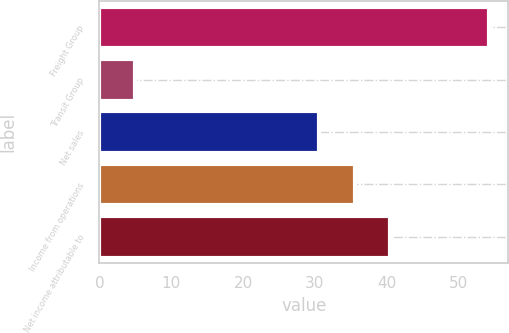<chart> <loc_0><loc_0><loc_500><loc_500><bar_chart><fcel>Freight Group<fcel>Transit Group<fcel>Net sales<fcel>Income from operations<fcel>Net income attributable to<nl><fcel>54.2<fcel>4.9<fcel>30.6<fcel>35.53<fcel>40.46<nl></chart> 